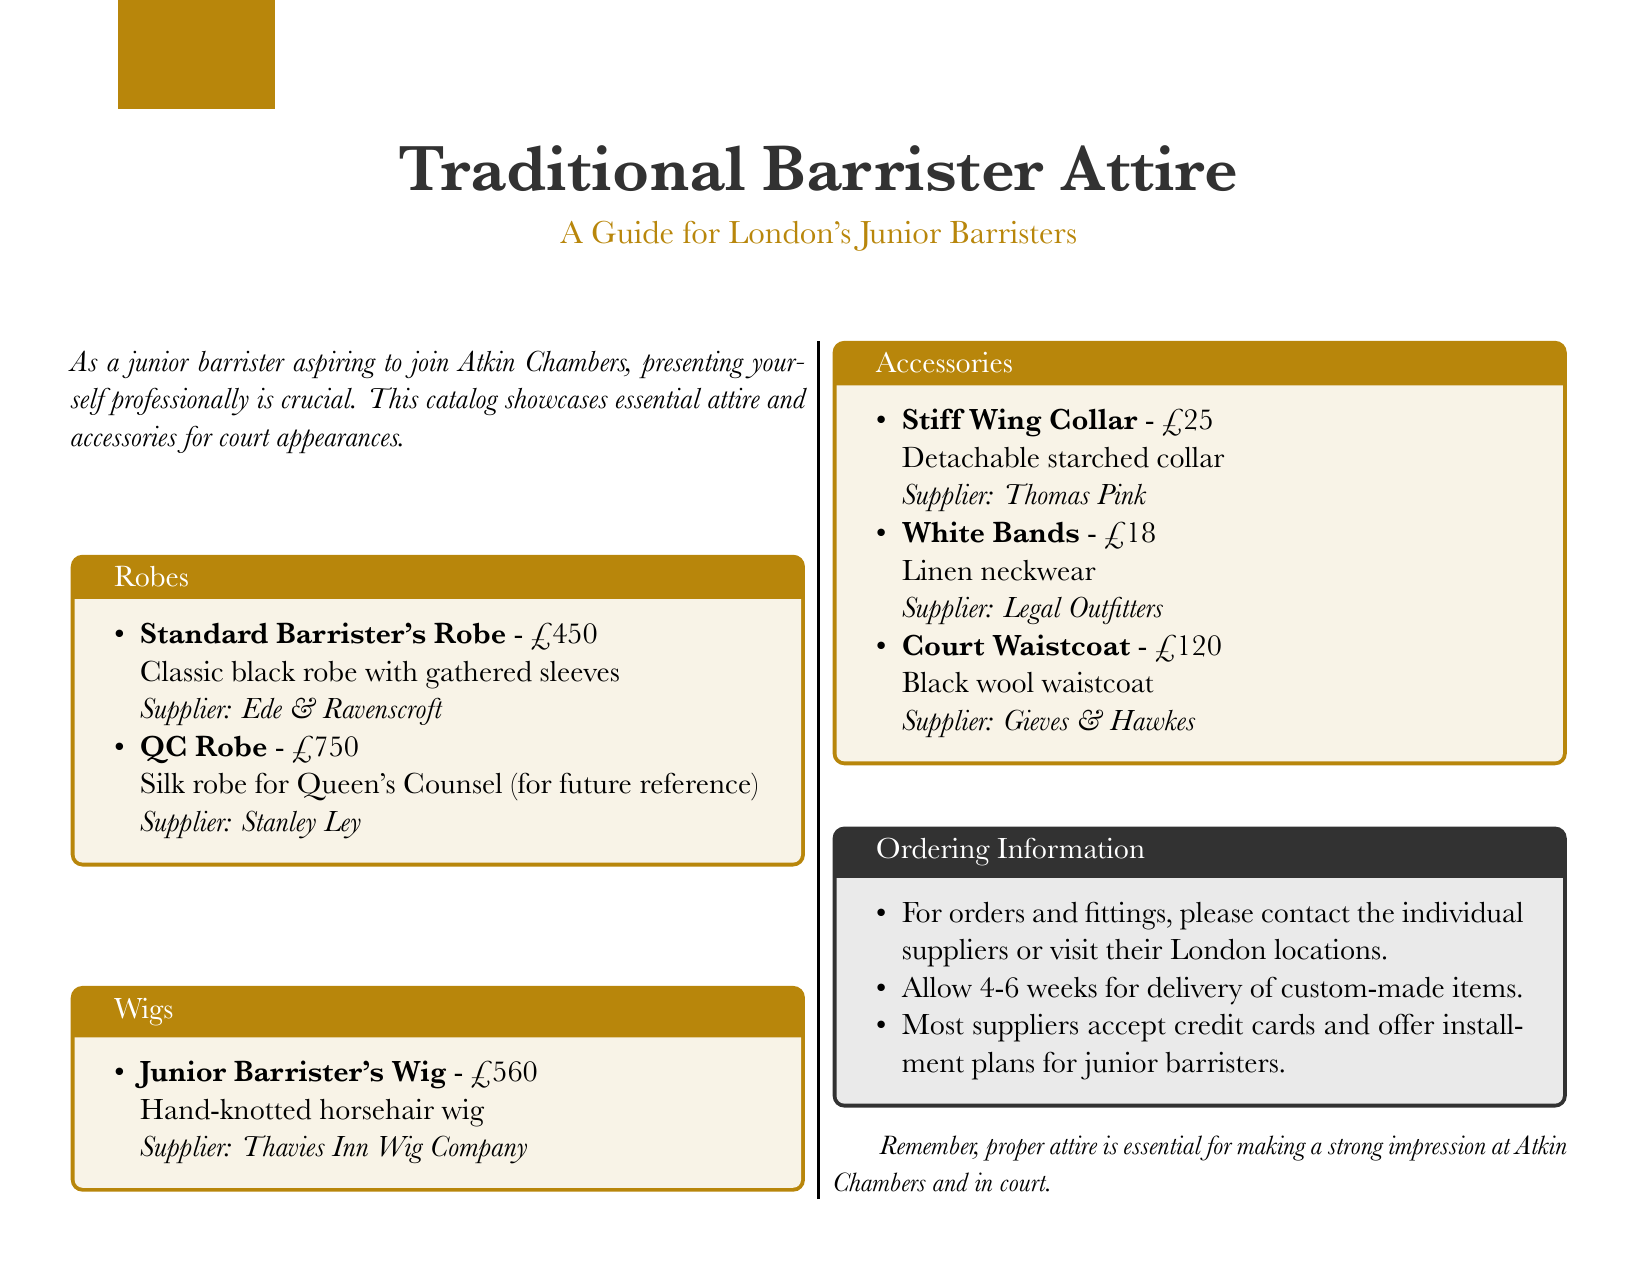what is the price of a Standard Barrister's Robe? The price is listed in the catalog under the robes section.
Answer: £450 who is the supplier for the Junior Barrister's Wig? The supplier's name is included next to the wig description in the catalog.
Answer: Thavies Inn Wig Company what type of collar is listed as an accessory? The catalog specifies the type of collar available in the accessories section.
Answer: Stiff Wing Collar how long should one allow for delivery of custom-made items? This information is provided in the ordering information section of the catalog.
Answer: 4-6 weeks what is the price of White Bands? The price is mentioned in the accessories list in the catalog.
Answer: £18 what is the material of the Court Waistcoat? The material is indicated in the accessories section of the catalog.
Answer: Black wool which robe is specifically mentioned for Queen's Counsel? This robe is detailed in the robes section, specifying its purpose.
Answer: QC Robe who supplies the Court Waistcoat? The name of the supplier is found in the accessories description.
Answer: Gieves & Hawkes what is the total cost for the complete set of accessories listed? The total is the sum of all accessory prices in the document: £25 + £18 + £120.
Answer: £163 